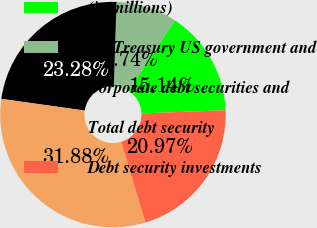<chart> <loc_0><loc_0><loc_500><loc_500><pie_chart><fcel>(in millions)<fcel>US Treasury US government and<fcel>Corporate debt securities and<fcel>Total debt security<fcel>Debt security investments<nl><fcel>15.14%<fcel>8.74%<fcel>23.28%<fcel>31.88%<fcel>20.97%<nl></chart> 